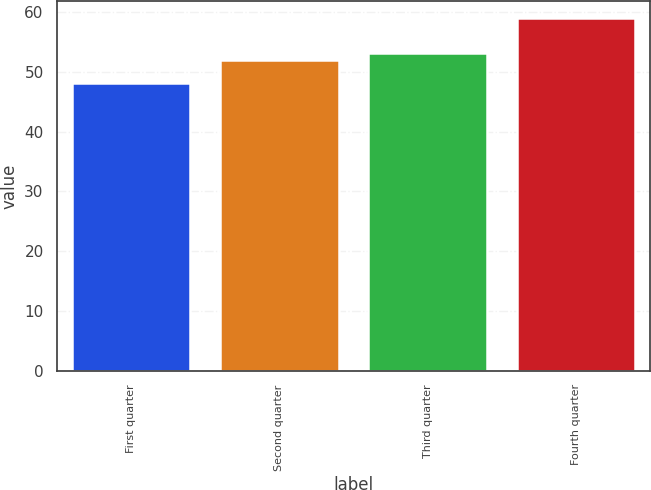Convert chart to OTSL. <chart><loc_0><loc_0><loc_500><loc_500><bar_chart><fcel>First quarter<fcel>Second quarter<fcel>Third quarter<fcel>Fourth quarter<nl><fcel>48.1<fcel>52.02<fcel>53.1<fcel>58.9<nl></chart> 